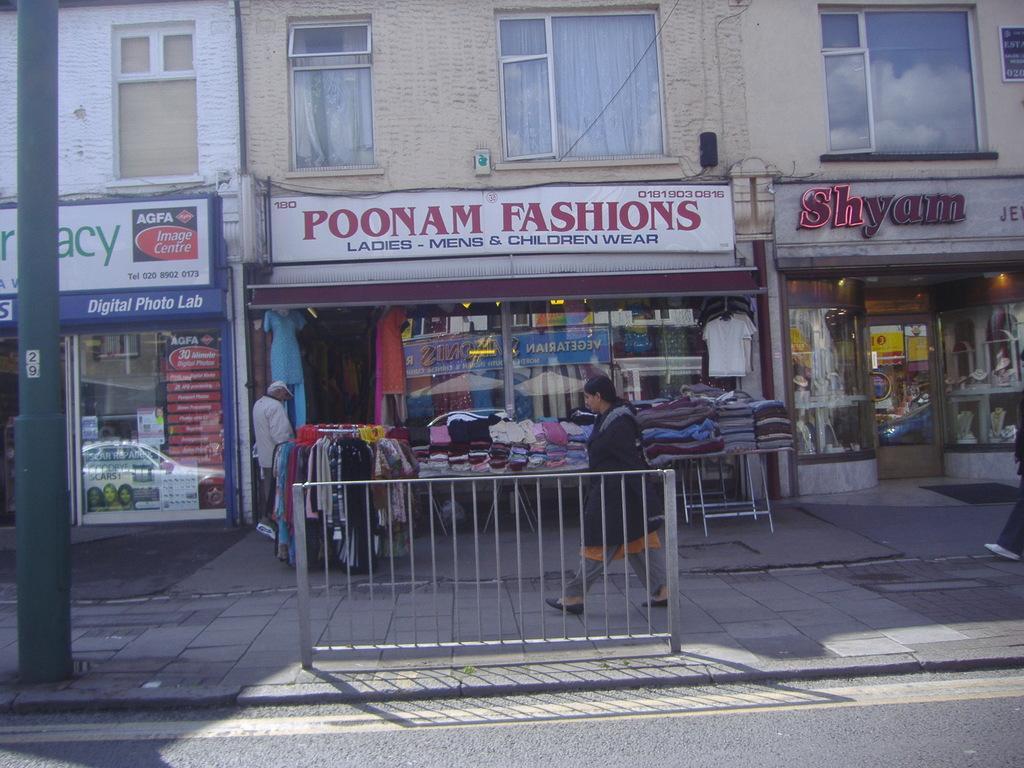Please provide a concise description of this image. In the foreground of this image, there is a road, a pole and railing. Behind it, there are few people standing and walking on the side path. We can also see few clothes, shops, windows and the wall of a building. 